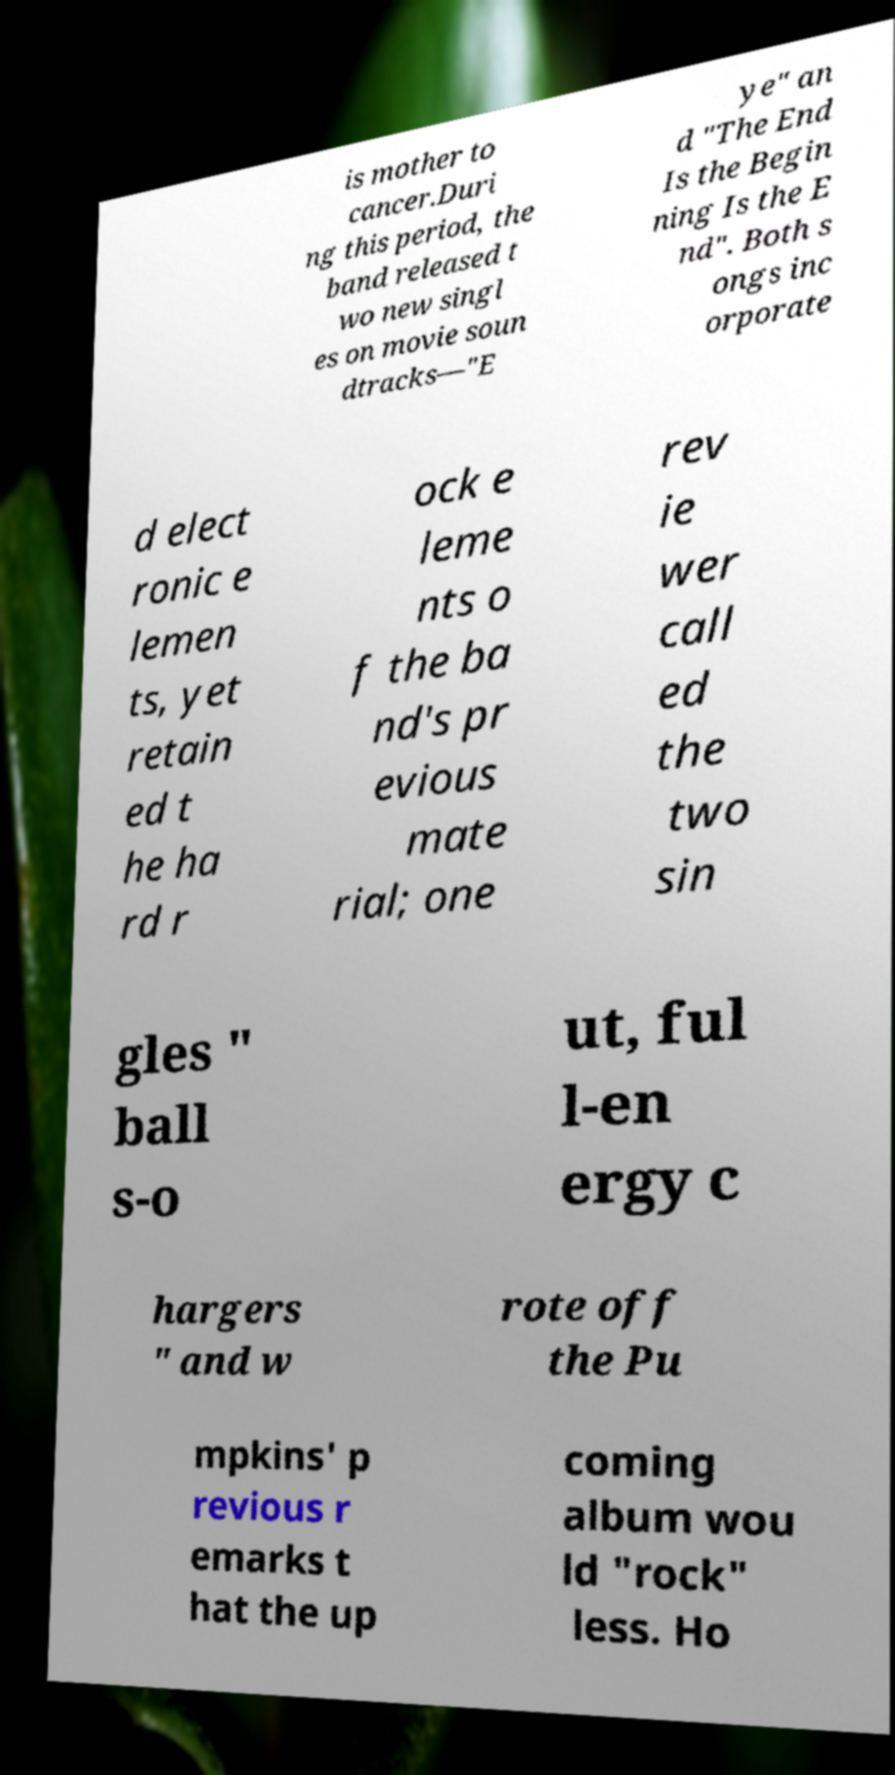Could you assist in decoding the text presented in this image and type it out clearly? is mother to cancer.Duri ng this period, the band released t wo new singl es on movie soun dtracks—"E ye" an d "The End Is the Begin ning Is the E nd". Both s ongs inc orporate d elect ronic e lemen ts, yet retain ed t he ha rd r ock e leme nts o f the ba nd's pr evious mate rial; one rev ie wer call ed the two sin gles " ball s-o ut, ful l-en ergy c hargers " and w rote off the Pu mpkins' p revious r emarks t hat the up coming album wou ld "rock" less. Ho 